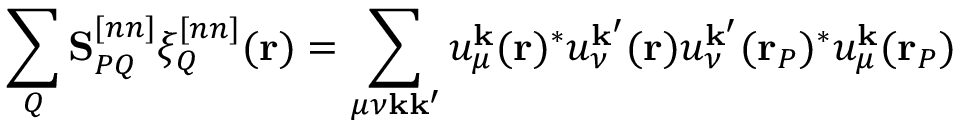<formula> <loc_0><loc_0><loc_500><loc_500>\sum _ { Q } \mathbf S _ { P Q } ^ { [ n n ] } \xi _ { Q } ^ { [ n n ] } ( r ) = \sum _ { \mu \nu k k ^ { \prime } } u _ { \mu } ^ { k } ( r ) ^ { * } u _ { \nu } ^ { k ^ { \prime } } ( r ) u _ { \nu } ^ { k ^ { \prime } } ( r _ { P } ) ^ { * } u _ { \mu } ^ { k } ( r _ { P } )</formula> 